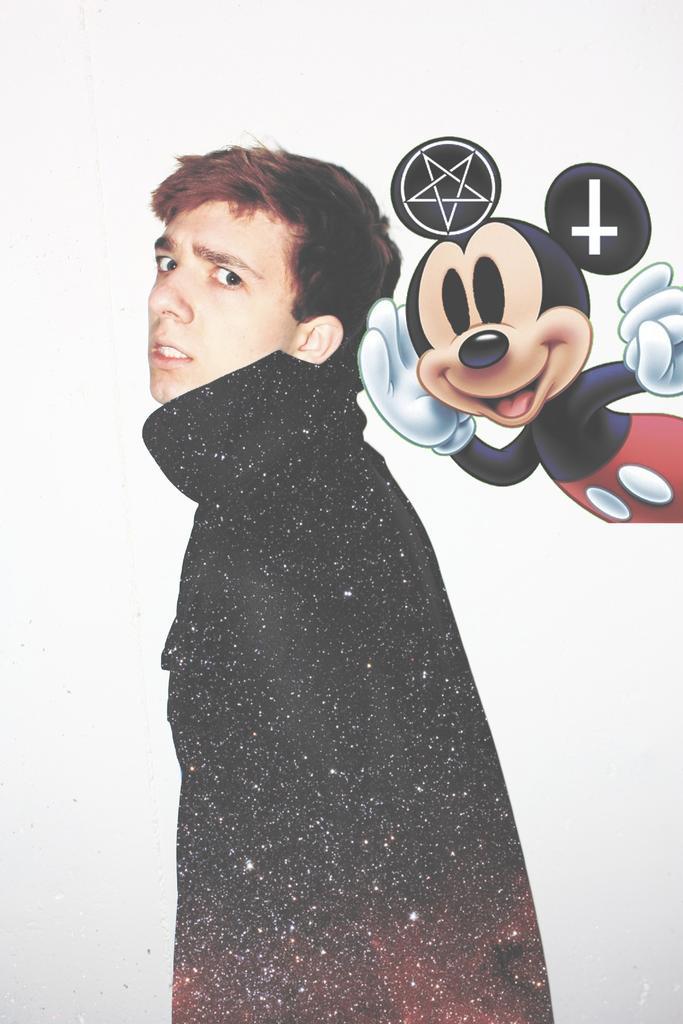In one or two sentences, can you explain what this image depicts? In this picture there is a person wearing black jacket is standing and there is a mickey mouse image behind him. 